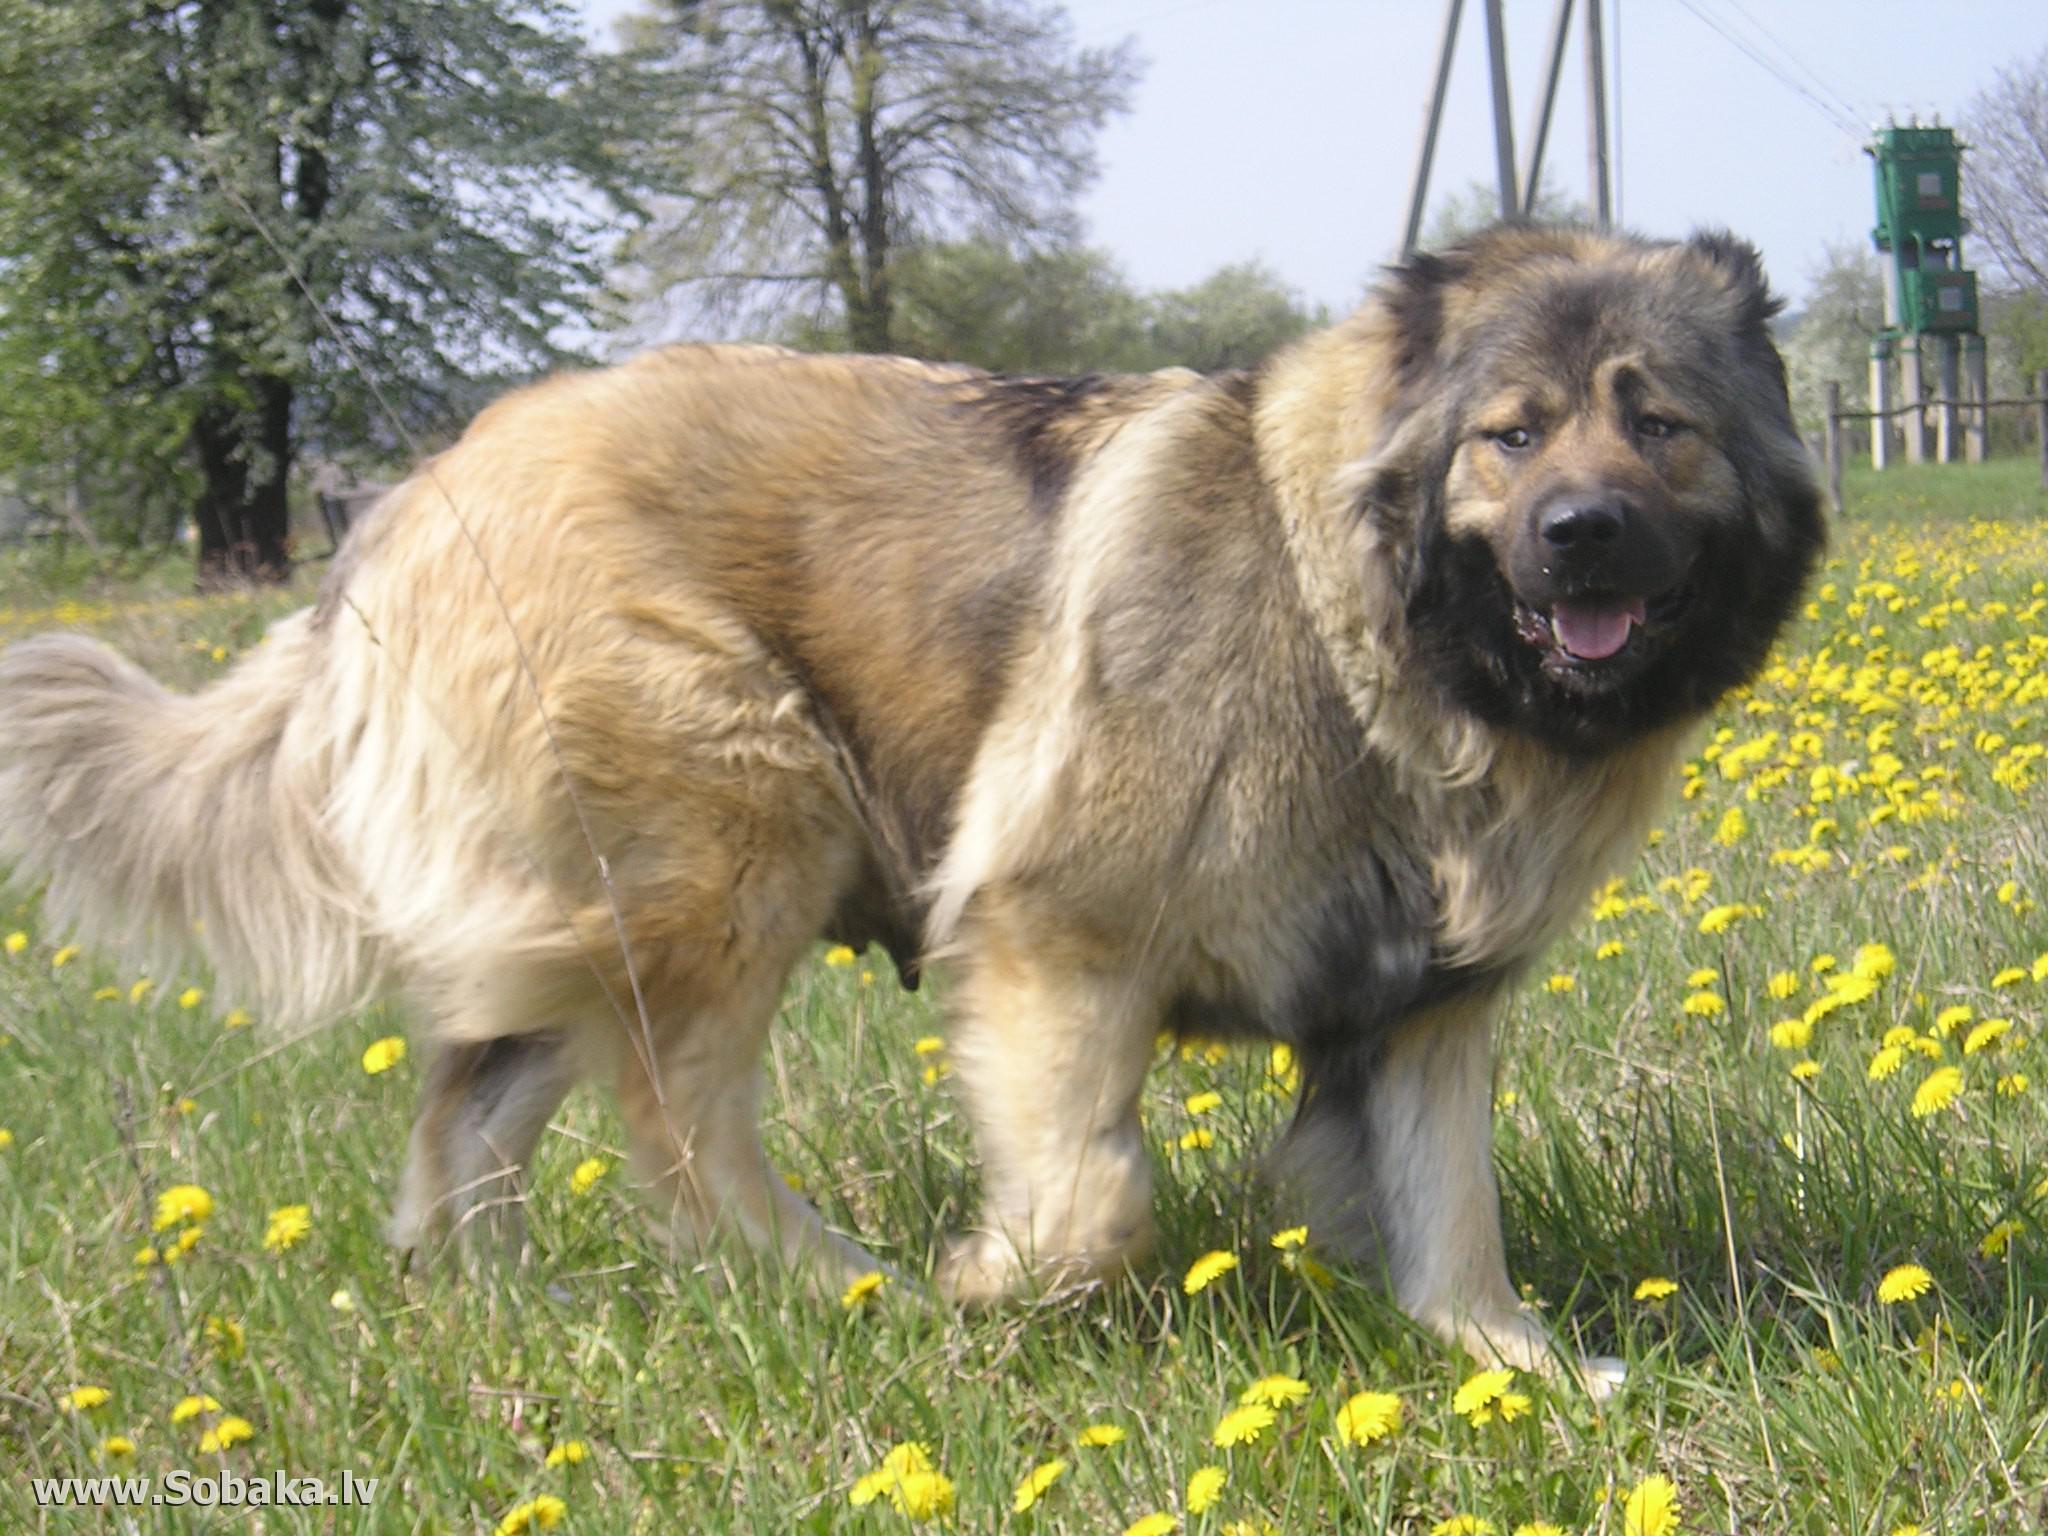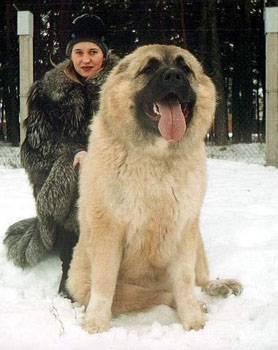The first image is the image on the left, the second image is the image on the right. Evaluate the accuracy of this statement regarding the images: "One of the photos shows one or more dogs outside in the snow.". Is it true? Answer yes or no. Yes. The first image is the image on the left, the second image is the image on the right. Considering the images on both sides, is "One image shows at least one dog on snowy ground." valid? Answer yes or no. Yes. 